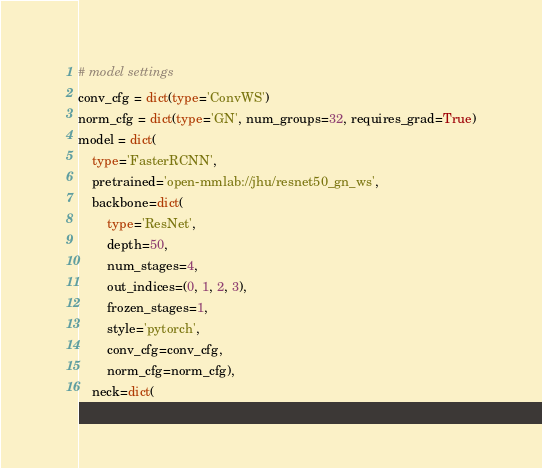Convert code to text. <code><loc_0><loc_0><loc_500><loc_500><_Python_># model settings
conv_cfg = dict(type='ConvWS')
norm_cfg = dict(type='GN', num_groups=32, requires_grad=True)
model = dict(
    type='FasterRCNN',
    pretrained='open-mmlab://jhu/resnet50_gn_ws',
    backbone=dict(
        type='ResNet',
        depth=50,
        num_stages=4,
        out_indices=(0, 1, 2, 3),
        frozen_stages=1,
        style='pytorch',
        conv_cfg=conv_cfg,
        norm_cfg=norm_cfg),
    neck=dict(</code> 